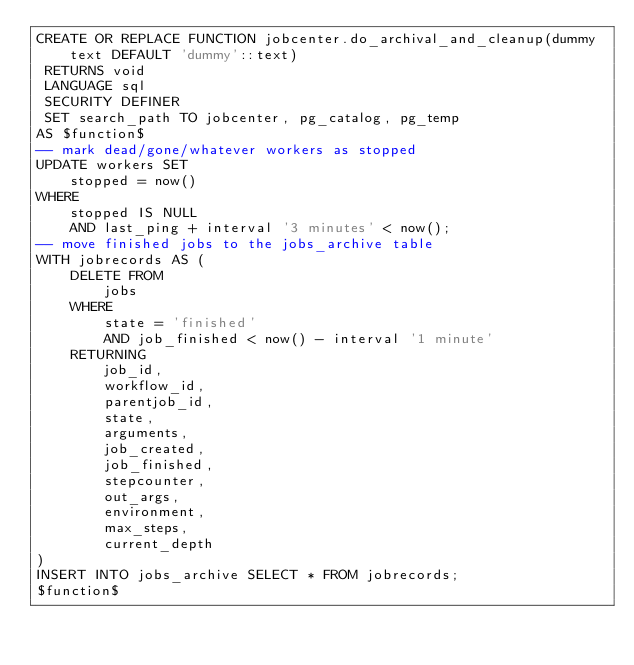Convert code to text. <code><loc_0><loc_0><loc_500><loc_500><_SQL_>CREATE OR REPLACE FUNCTION jobcenter.do_archival_and_cleanup(dummy text DEFAULT 'dummy'::text)
 RETURNS void
 LANGUAGE sql
 SECURITY DEFINER
 SET search_path TO jobcenter, pg_catalog, pg_temp
AS $function$
-- mark dead/gone/whatever workers as stopped
UPDATE workers SET
	stopped = now()
WHERE
	stopped IS NULL
	AND last_ping + interval '3 minutes' < now();
-- move finished jobs to the jobs_archive table
WITH jobrecords AS (
	DELETE FROM
		jobs
	WHERE
		state = 'finished'
		AND job_finished < now() - interval '1 minute'
	RETURNING
		job_id,
		workflow_id,
		parentjob_id,
		state,
		arguments,
		job_created,
		job_finished,
		stepcounter,
		out_args,
		environment,
		max_steps,
		current_depth
)
INSERT INTO jobs_archive SELECT * FROM jobrecords;
$function$
</code> 